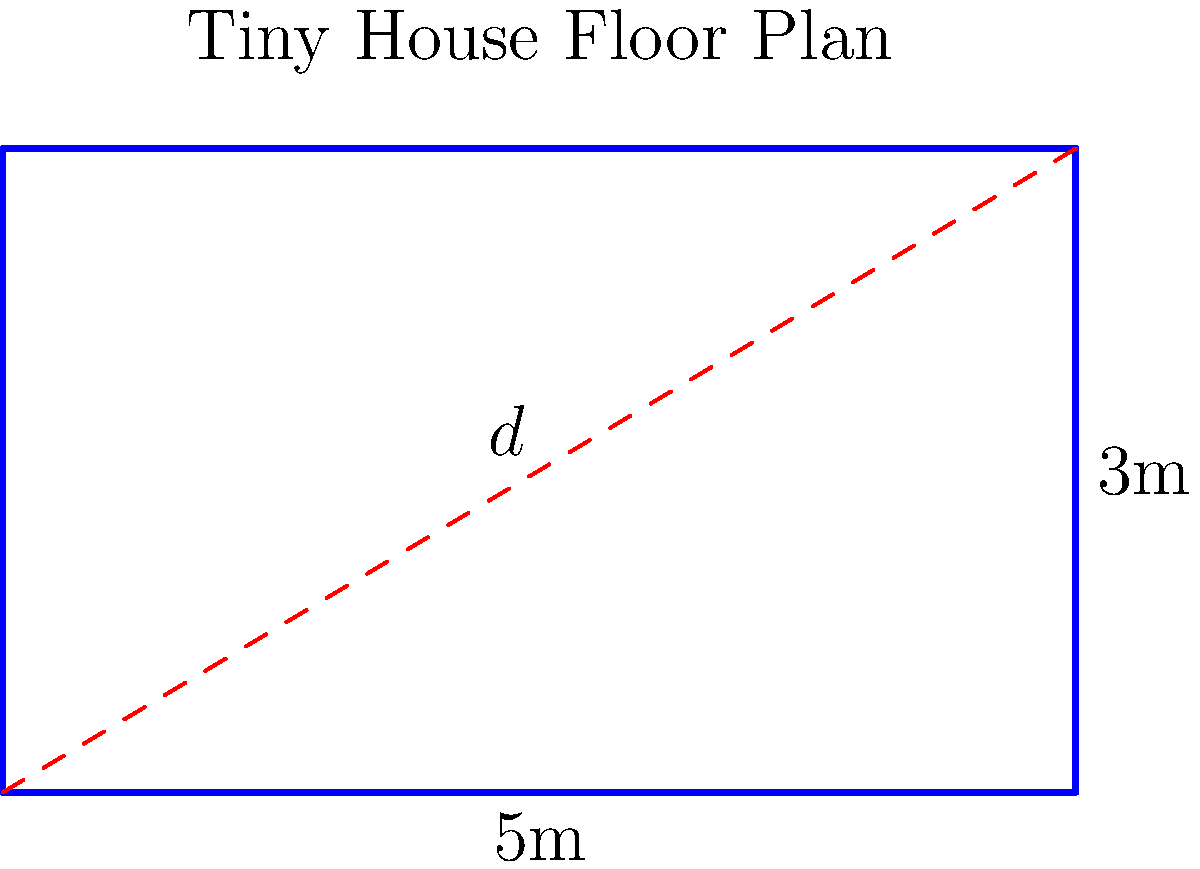In designing a space-efficient tiny house, you're working with a rectangular floor plan that measures 5m by 3m. To maximize storage options, you want to install a diagonal shelf from one corner to the opposite corner. What is the length of this diagonal shelf to the nearest centimeter? Let's approach this step-by-step:

1) The floor plan forms a right-angled triangle when we consider the diagonal.

2) We can use the Pythagorean theorem to calculate the length of the diagonal. Let's call the diagonal $d$.

3) According to the Pythagorean theorem:
   $d^2 = 5^2 + 3^2$

4) Let's solve this equation:
   $d^2 = 25 + 9 = 34$

5) To find $d$, we need to take the square root of both sides:
   $d = \sqrt{34}$

6) Using a calculator or computer:
   $d \approx 5.8309518948453$

7) Rounding to the nearest centimeter:
   $d \approx 5.83$ m or 583 cm

Despite the space constraints, this diagonal shelf could provide a creative storage solution, turning a potential challenge into an opportunity for innovative design - a perfect example of finding a silver lining in a challenging situation.
Answer: 583 cm 